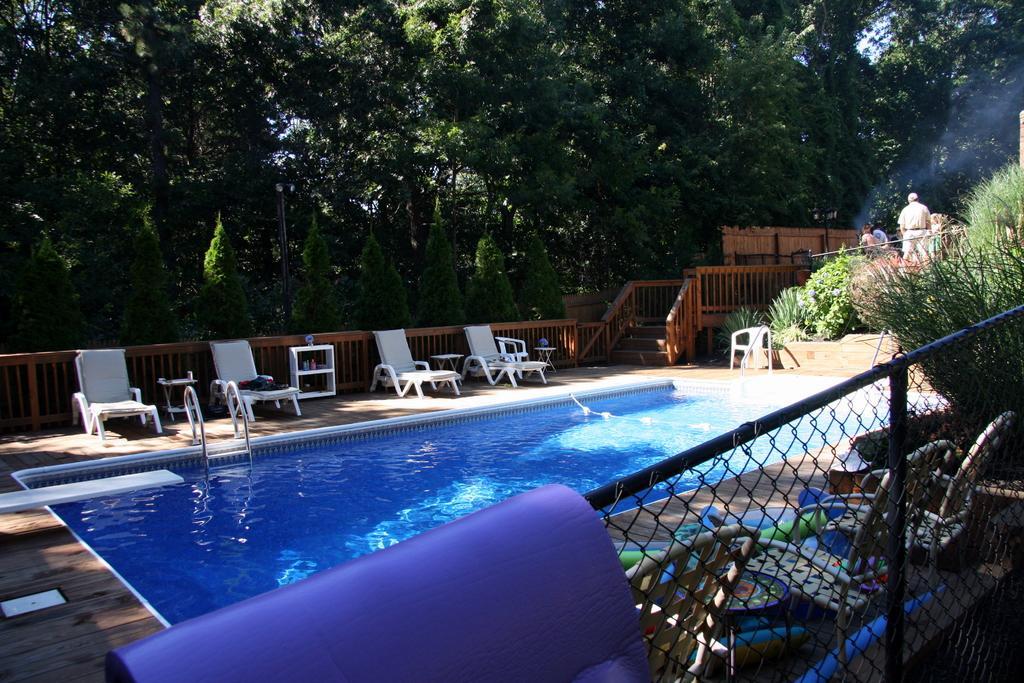Please provide a concise description of this image. In the center of the picture there is a swimming pool, around the pool there are beaches chairs and other objects. In the foreground it is railing. On the right there are plants, people and other objects. In the background there are trees. 